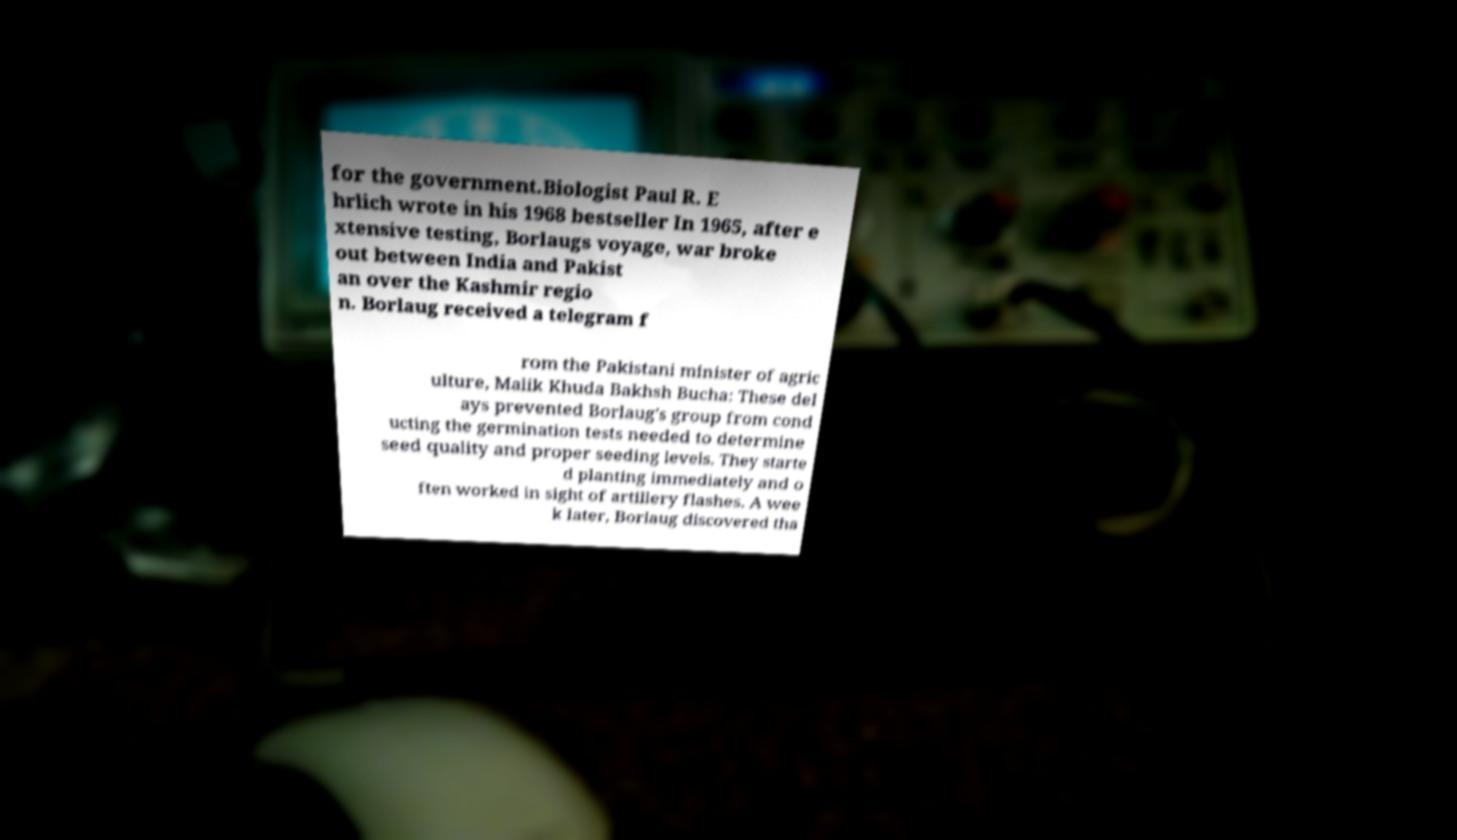For documentation purposes, I need the text within this image transcribed. Could you provide that? for the government.Biologist Paul R. E hrlich wrote in his 1968 bestseller In 1965, after e xtensive testing, Borlaugs voyage, war broke out between India and Pakist an over the Kashmir regio n. Borlaug received a telegram f rom the Pakistani minister of agric ulture, Malik Khuda Bakhsh Bucha: These del ays prevented Borlaug's group from cond ucting the germination tests needed to determine seed quality and proper seeding levels. They starte d planting immediately and o ften worked in sight of artillery flashes. A wee k later, Borlaug discovered tha 